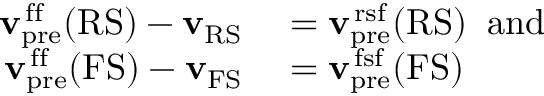<formula> <loc_0><loc_0><loc_500><loc_500>\begin{array} { r l } { { v } _ { p r e } ^ { \, f f } ( R S ) - { v } _ { R S } } & = { v } _ { p r e } ^ { \, r s f } ( R S ) \, a n d } \\ { { v } _ { p r e } ^ { \, f f } ( F S ) - { v } _ { F S } } & = { v } _ { p r e } ^ { \, f s f } ( F S ) } \end{array}</formula> 